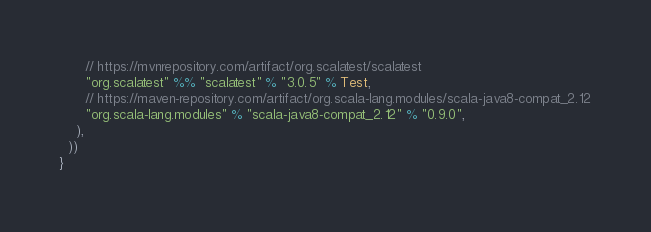Convert code to text. <code><loc_0><loc_0><loc_500><loc_500><_Scala_>      // https://mvnrepository.com/artifact/org.scalatest/scalatest
      "org.scalatest" %% "scalatest" % "3.0.5" % Test,
      // https://maven-repository.com/artifact/org.scala-lang.modules/scala-java8-compat_2.12
      "org.scala-lang.modules" % "scala-java8-compat_2.12" % "0.9.0",
    ),
  ))
}
</code> 